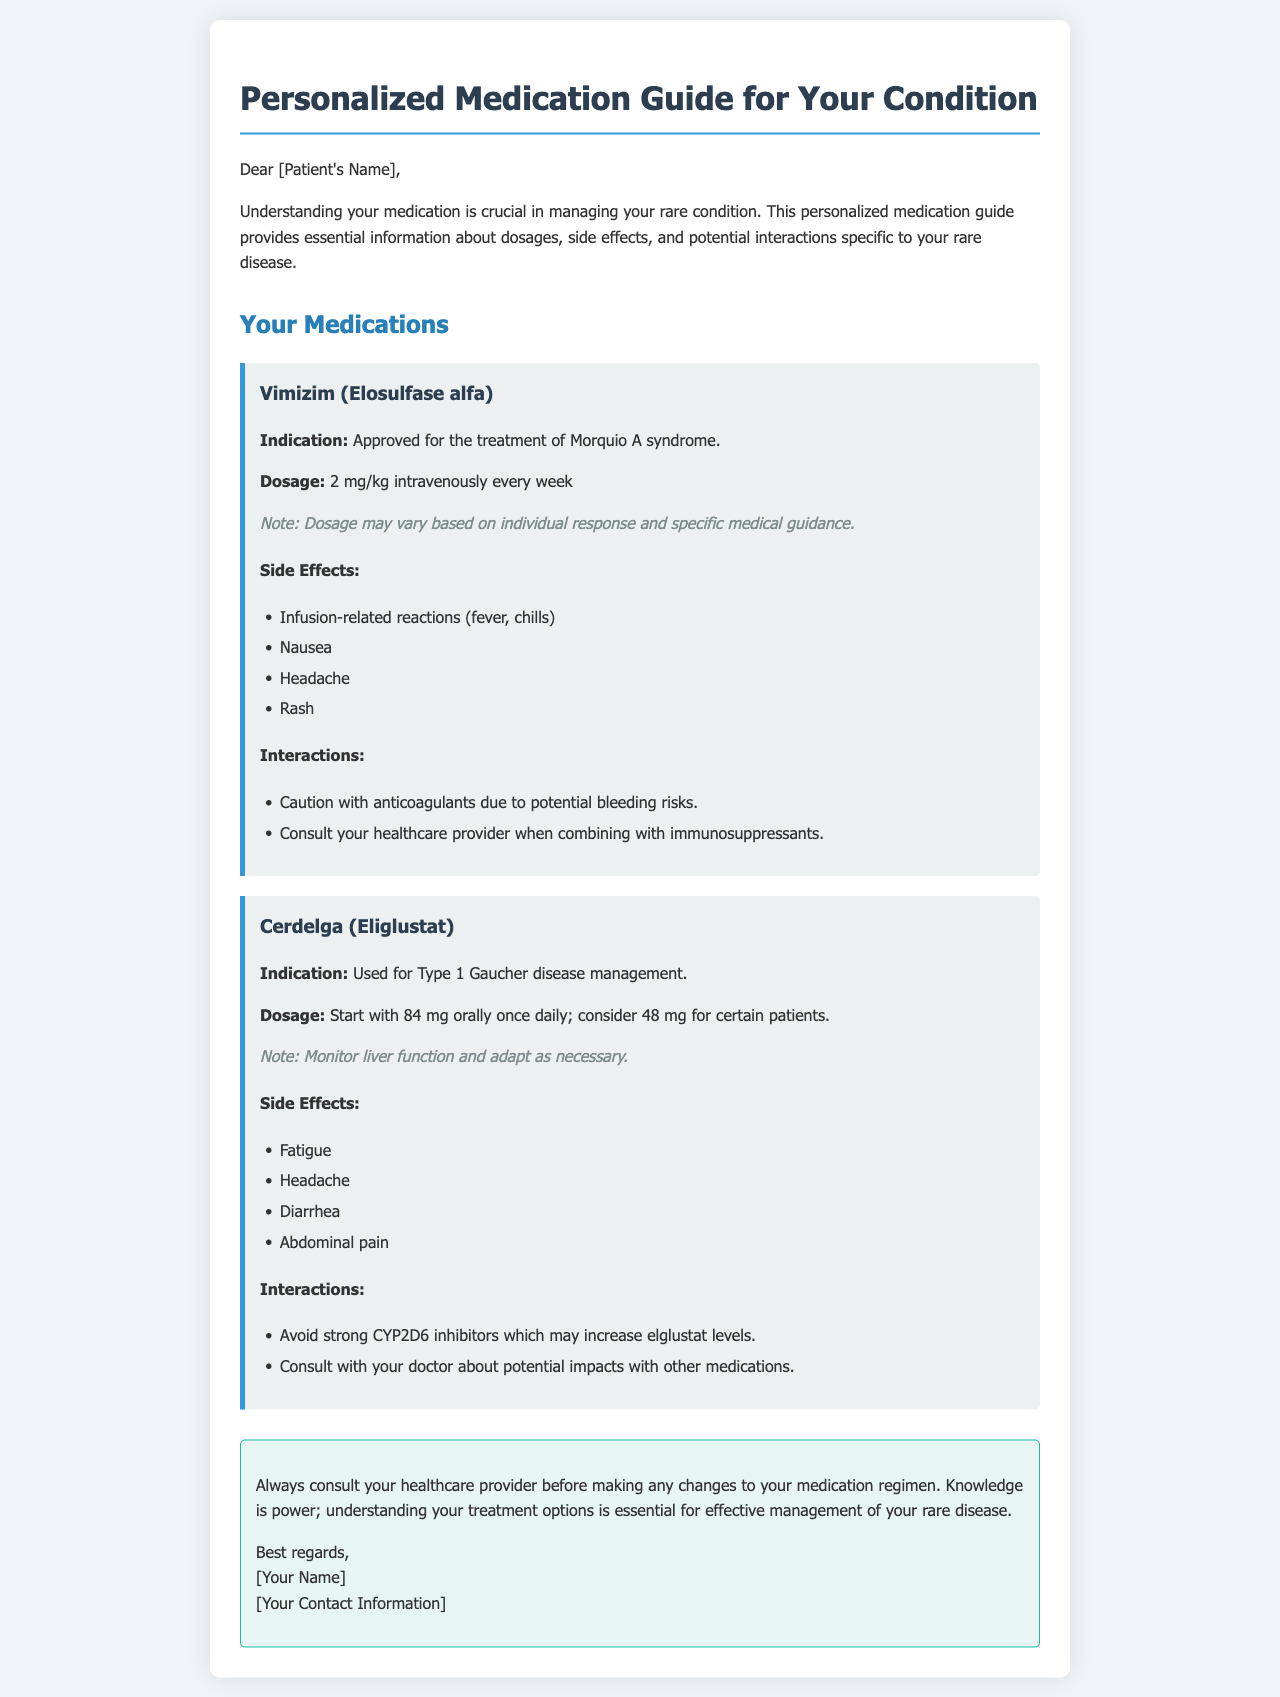What is the main topic of the document? The document provides a personalized medication guide specific to the patient's rare disease.
Answer: Personalized medication guide What is the dosage for Vimizim? The dosage for Vimizim is stated in the document as 2 mg/kg.
Answer: 2 mg/kg What are two side effects of Cerdelga? The side effects of Cerdelga are listed in the document, including fatigue and headache.
Answer: Fatigue, headache What is the indication for Vimizim? The indication for Vimizim is specifically mentioned in the document as being for Morquio A syndrome.
Answer: Morquio A syndrome What should be monitored when taking Cerdelga? The document notes that liver function should be monitored when taking Cerdelga.
Answer: Liver function What caution is advised with Vimizim? Caution is advised with anticoagulants due to potential bleeding risks, as stated in the document.
Answer: Anticoagulants What is the starting dosage for Cerdelga? The starting dosage for Cerdelga is mentioned in the document as 84 mg orally once daily.
Answer: 84 mg Why is it important to consult a healthcare provider? The document emphasizes consulting a healthcare provider to ensure proper medication regimen management.
Answer: Medication regimen management What document type does this content represent? The structure and content indicate it is a personalized medication guide.
Answer: Personalized medication guide 